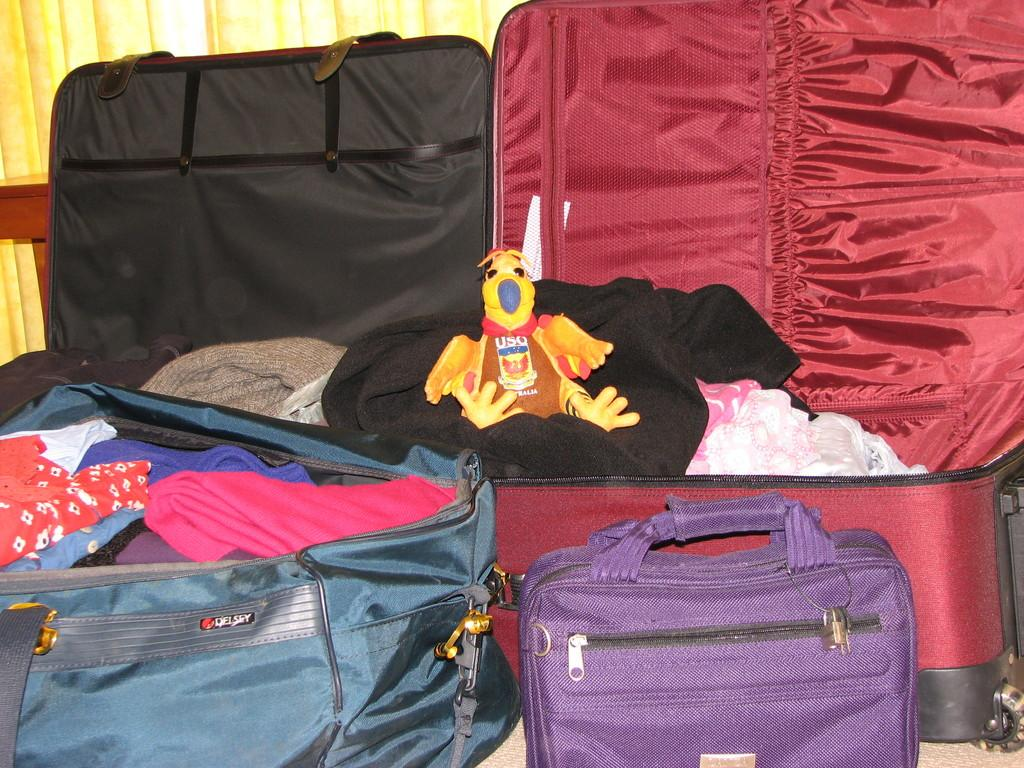What is inside the bags that are visible in the image? There are bags filled with clothes in the image. Are all the bags closed, or are some open? Some of the bags are open. Can you describe the placement of the duck in the image? There is a duck placed in a red bag. What can be seen in the background of the image? There is a yellow curtain in the background of the image. What type of furniture is being used to support the bags in the image? There is no furniture visible in the image; the bags are simply placed on the floor or another surface. 